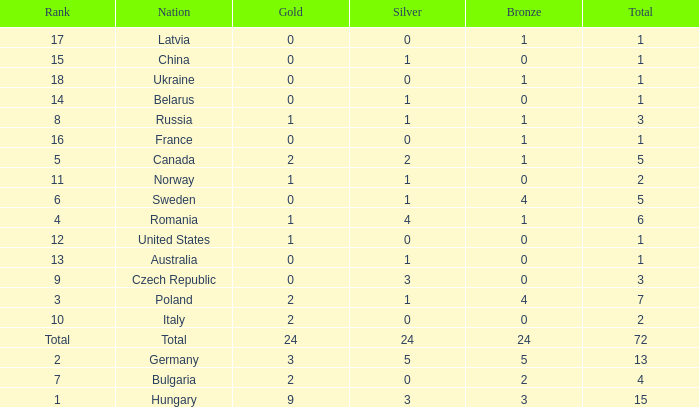What nation has 0 as the silver, 1 as the bronze, with 18 as the rank? Ukraine. 